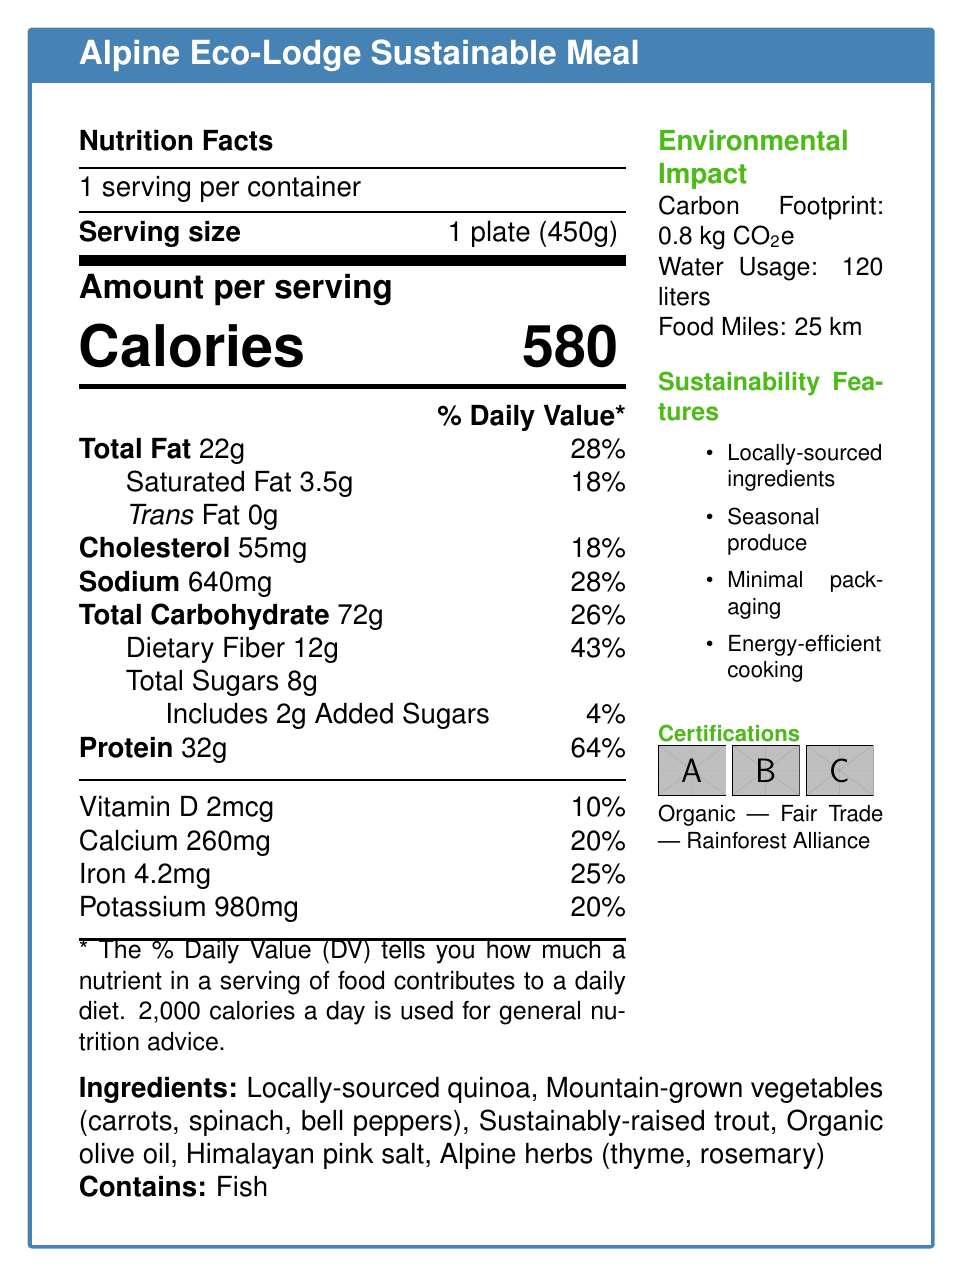what is the serving size of the Alpine Eco-Lodge Sustainable Meal? The serving size is listed as "1 plate (450g)" in the nutrition facts section.
Answer: 1 plate (450g) how many calories are in one serving of the meal? The document states that there are "Calories 580" per serving.
Answer: 580 what percentage of the daily value of dietary fiber does one serving provide? The dietary fiber content is listed as providing 43% of the daily value.
Answer: 43% what is the environmental impact in terms of water usage for this meal? The environmental impact section states that the water usage is "120 liters."
Answer: 120 liters what are the main protein sources listed in the ingredients? The ingredient list includes "Sustainably-raised trout" as the protein source.
Answer: Sustainably-raised trout what certifications does this meal have? A. USDA Organic, Kosher, Non-GMO B. Organic, Fair Trade, Rainforest Alliance C. Fair Trade, Gluten-Free, Vegan The document lists "Organic," "Fair Trade," and "Rainforest Alliance" as the certifications.
Answer: B which of the following is NOT a sustainability feature mentioned in the document? A. Locally-sourced ingredients B. Minimal packaging C. Use of plastic utensils D. Energy-efficient cooking The sustainability features listed are "Locally-sourced ingredients," "Minimal packaging," and "Energy-efficient cooking." Use of plastic utensils is not mentioned.
Answer: C does the meal contain any added sugars? The nutrition facts indicate that the meal includes 2g of added sugars.
Answer: Yes does the meal support local biodiversity? The ecosystem benefits section states that the meal "Supports local biodiversity."
Answer: Yes describe the main idea of the document. The document is an informative piece that gives a comprehensive overview of the Alpine Eco-Lodge Sustainable Meal, including its nutritional content, environmental benefits, and sustainability features. It also considers the effects of tourism on local ecosystems and promotes responsible consumption habits.
Answer: The document provides detailed nutrition facts, ingredients, environmental impact, certifications, and sustainability and ecosystem benefits of the Alpine Eco-Lodge Sustainable Meal. It highlights its positive impact on local ecosystems, sustainable ingredient sourcing, and responsible tourism practices. However, it also mentions potential negative impacts on local resources. how are food miles relevant to the sustainability of the meal? The document mentions that the food miles are 25 km but does not elaborate on how this specifically contributes to the sustainability of the meal.
Answer: Not enough information 